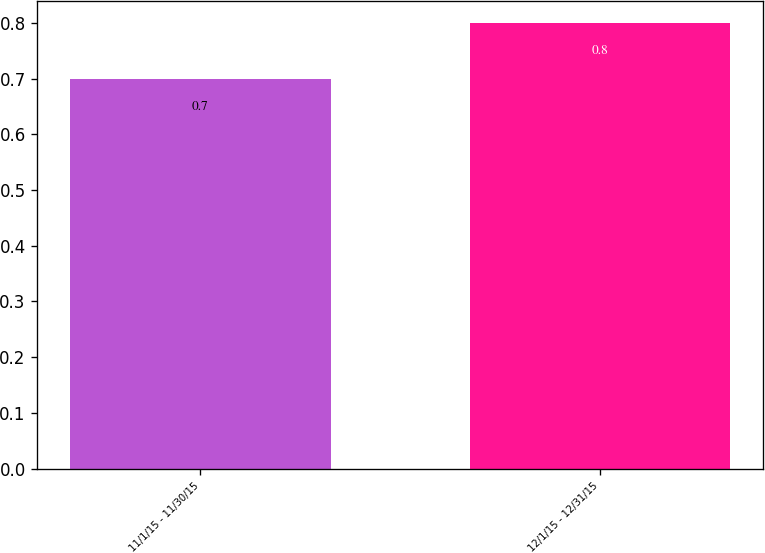Convert chart. <chart><loc_0><loc_0><loc_500><loc_500><bar_chart><fcel>11/1/15 - 11/30/15<fcel>12/1/15 - 12/31/15<nl><fcel>0.7<fcel>0.8<nl></chart> 